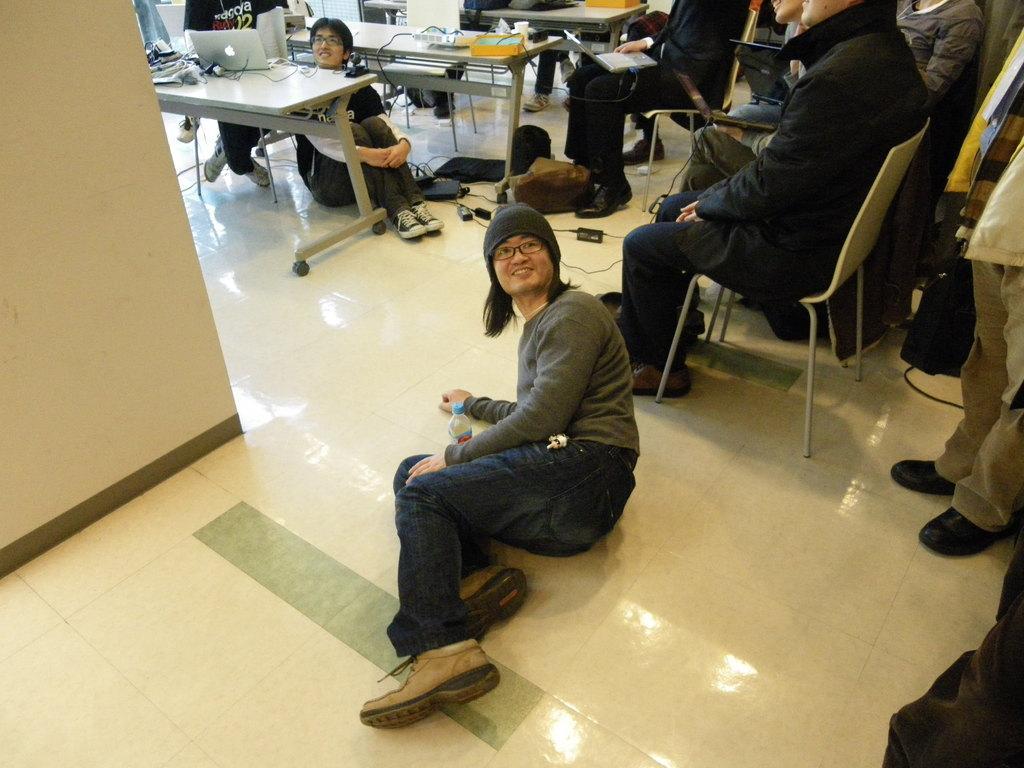In one or two sentences, can you explain what this image depicts? In this image I see lot of people who are sitting on the chairs and 2 of them over here are on the ground. I also see that there are few tables and few things on it. 